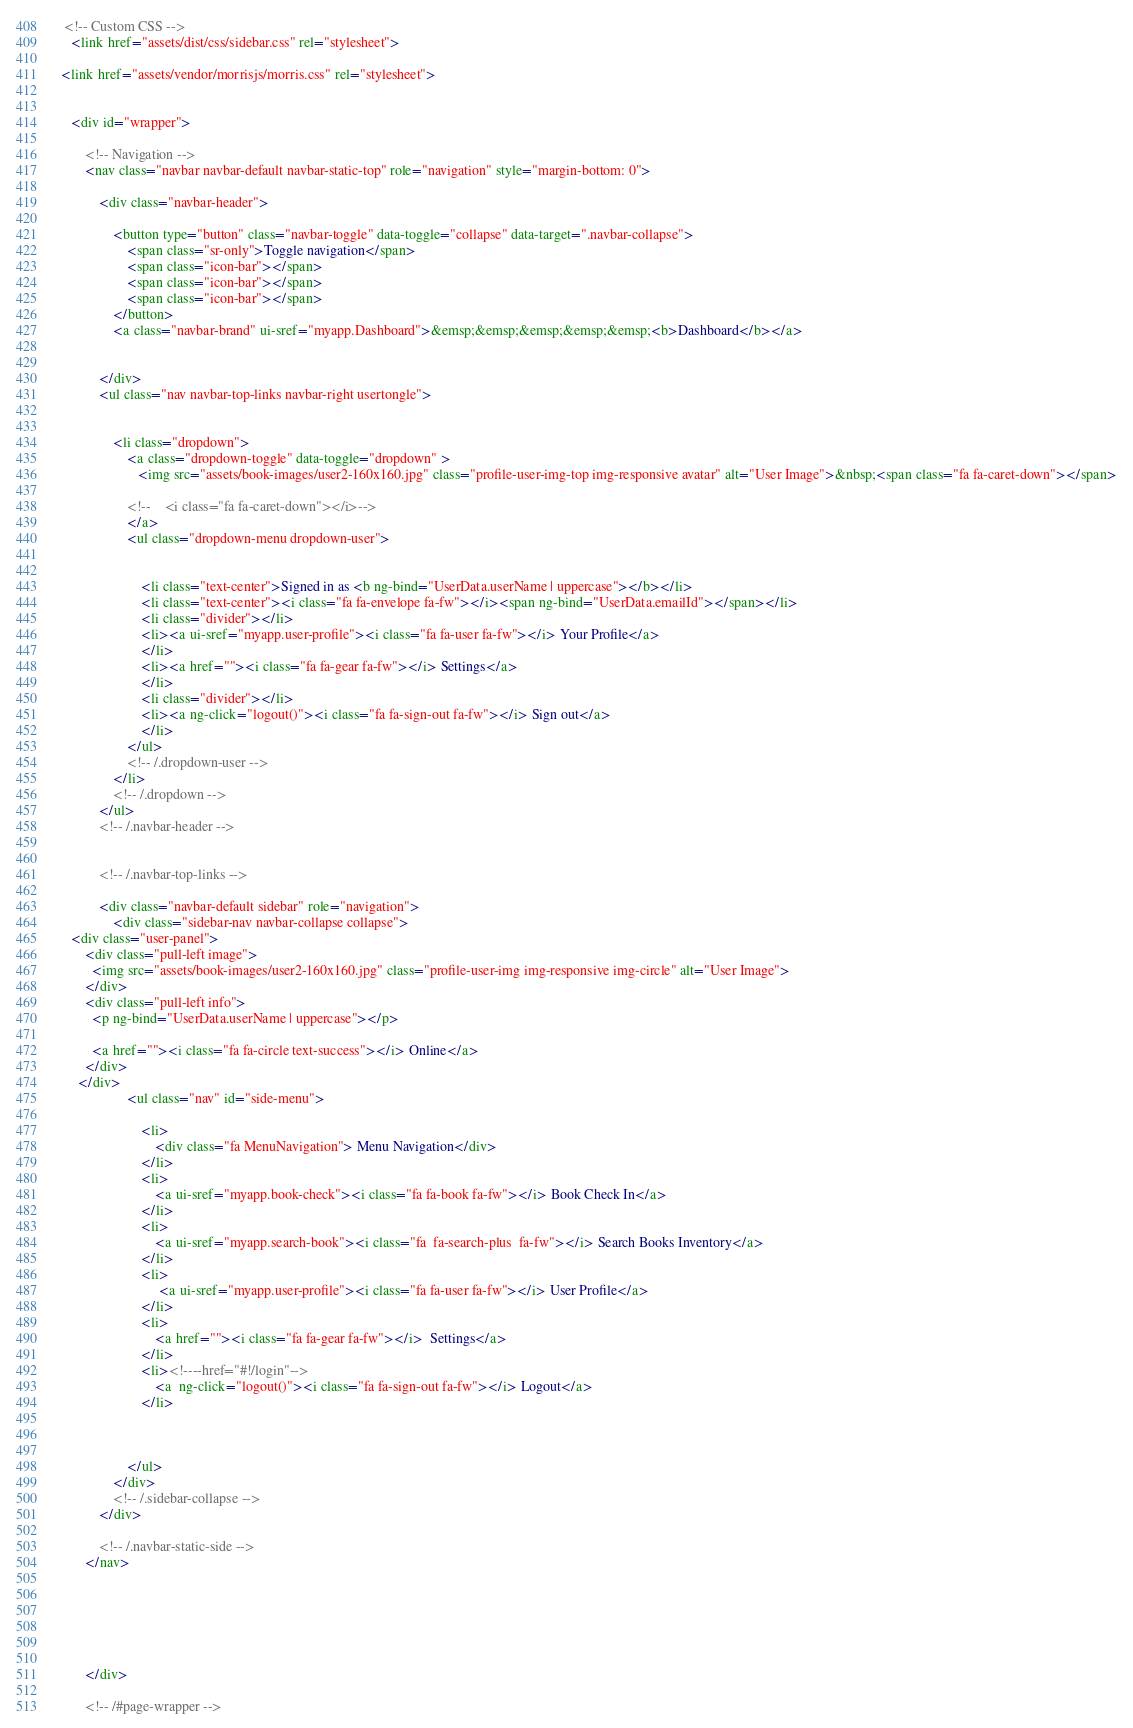<code> <loc_0><loc_0><loc_500><loc_500><_HTML_>  <!-- Custom CSS -->
    <link href="assets/dist/css/sidebar.css" rel="stylesheet">
 
 <link href="assets/vendor/morrisjs/morris.css" rel="stylesheet">
 

    <div id="wrapper">

        <!-- Navigation -->
        <nav class="navbar navbar-default navbar-static-top" role="navigation" style="margin-bottom: 0">
		
            <div class="navbar-header">
			  
                <button type="button" class="navbar-toggle" data-toggle="collapse" data-target=".navbar-collapse">
                    <span class="sr-only">Toggle navigation</span>
                    <span class="icon-bar"></span>
                    <span class="icon-bar"></span>
                    <span class="icon-bar"></span>
                </button>
                <a class="navbar-brand" ui-sref="myapp.Dashboard">&emsp;&emsp;&emsp;&emsp;&emsp;<b>Dashboard</b></a>
				
				
            </div> 
			<ul class="nav navbar-top-links navbar-right usertongle">
               
                
                <li class="dropdown">
                    <a class="dropdown-toggle" data-toggle="dropdown" >
                       <img src="assets/book-images/user2-160x160.jpg" class="profile-user-img-top img-responsive avatar" alt="User Image">&nbsp;<span class="fa fa-caret-down"></span>
                       				   
					<!--	<i class="fa fa-caret-down"></i>-->
                    </a>
                    <ul class="dropdown-menu dropdown-user">
					    
						
						<li class="text-center">Signed in as <b ng-bind="UserData.userName | uppercase"></b></li>
						<li class="text-center"><i class="fa fa-envelope fa-fw"></i><span ng-bind="UserData.emailId"></span></li>
						<li class="divider"></li>
                        <li><a ui-sref="myapp.user-profile"><i class="fa fa-user fa-fw"></i> Your Profile</a>
                        </li> 
                        <li><a href=""><i class="fa fa-gear fa-fw"></i> Settings</a>
                        </li>
                        <li class="divider"></li>
                        <li><a ng-click="logout()"><i class="fa fa-sign-out fa-fw"></i> Sign out</a>
                        </li>
                    </ul>
                    <!-- /.dropdown-user -->
                </li>
                <!-- /.dropdown -->
            </ul>
            <!-- /.navbar-header -->
               
    
            <!-- /.navbar-top-links -->

            <div class="navbar-default sidebar" role="navigation">
                <div class="sidebar-nav navbar-collapse collapse">
	<div class="user-panel">
        <div class="pull-left image">
          <img src="assets/book-images/user2-160x160.jpg" class="profile-user-img img-responsive img-circle" alt="User Image">
        </div>
        <div class="pull-left info">
          <p ng-bind="UserData.userName | uppercase"></p>
		  
          <a href=""><i class="fa fa-circle text-success"></i> Online</a>
        </div>
      </div>			
                    <ul class="nav" id="side-menu">
                      
                        <li>
                            <div class="fa MenuNavigation"> Menu Navigation</div>
                        </li>
						<li>
                            <a ui-sref="myapp.book-check"><i class="fa fa-book fa-fw"></i> Book Check In</a>
                        </li>
						<li>
                            <a ui-sref="myapp.search-book"><i class="fa  fa-search-plus  fa-fw"></i> Search Books Inventory</a>
                        </li>
						<li>
						     <a ui-sref="myapp.user-profile"><i class="fa fa-user fa-fw"></i> User Profile</a>
                        </li>
						<li>
                            <a href=""><i class="fa fa-gear fa-fw"></i>  Settings</a>
                        </li>
						<li><!----href="#!/login"-->
                            <a  ng-click="logout()"><i class="fa fa-sign-out fa-fw"></i> Logout</a>
                        </li>
						
                        
                        
                    </ul>
                </div>
                <!-- /.sidebar-collapse -->
            </div>
			
            <!-- /.navbar-static-side -->
        </nav>
		
		
		 
		

       
        </div>
     
        <!-- /#page-wrapper -->



</code> 